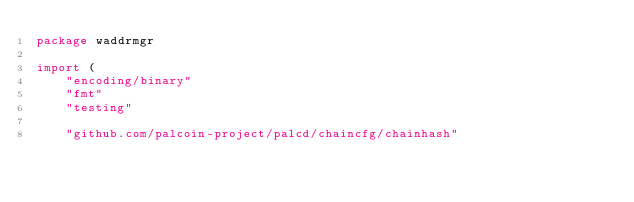Convert code to text. <code><loc_0><loc_0><loc_500><loc_500><_Go_>package waddrmgr

import (
	"encoding/binary"
	"fmt"
	"testing"

	"github.com/palcoin-project/palcd/chaincfg/chainhash"</code> 